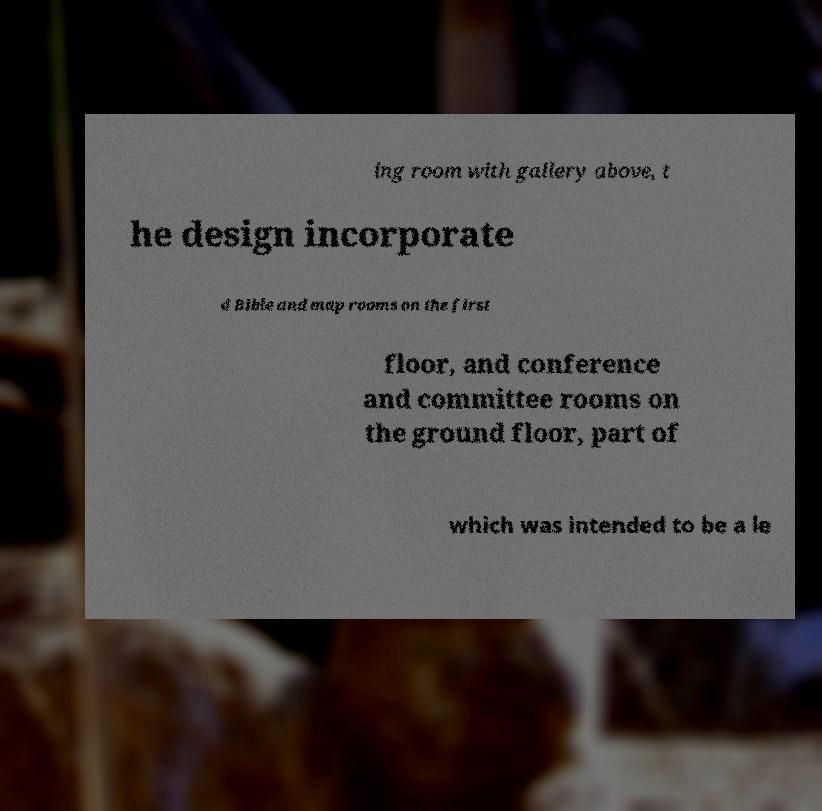Can you accurately transcribe the text from the provided image for me? ing room with gallery above, t he design incorporate d Bible and map rooms on the first floor, and conference and committee rooms on the ground floor, part of which was intended to be a le 